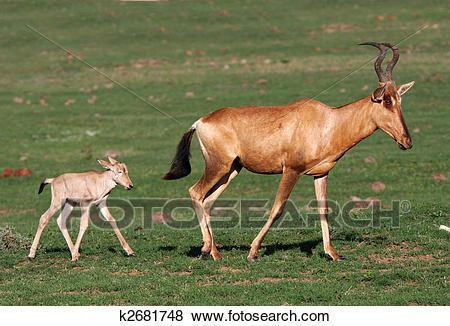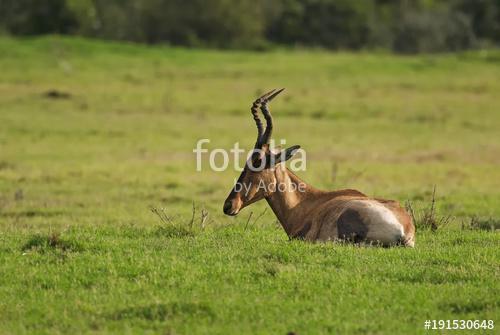The first image is the image on the left, the second image is the image on the right. Evaluate the accuracy of this statement regarding the images: "Exactly two animals are standing.". Is it true? Answer yes or no. Yes. The first image is the image on the left, the second image is the image on the right. Analyze the images presented: Is the assertion "One of the images shows a mommy and a baby animal together, but not touching." valid? Answer yes or no. Yes. 